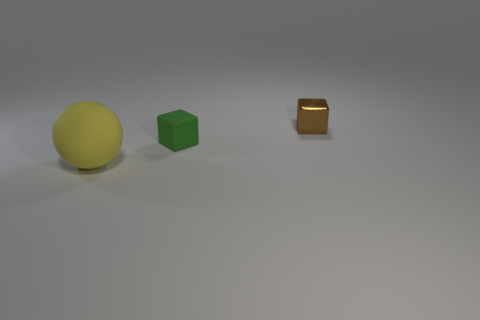Add 1 cyan shiny spheres. How many objects exist? 4 Subtract all cubes. How many objects are left? 1 Add 1 big rubber balls. How many big rubber balls exist? 2 Subtract 0 cyan cubes. How many objects are left? 3 Subtract all tiny brown objects. Subtract all gray shiny balls. How many objects are left? 2 Add 3 green cubes. How many green cubes are left? 4 